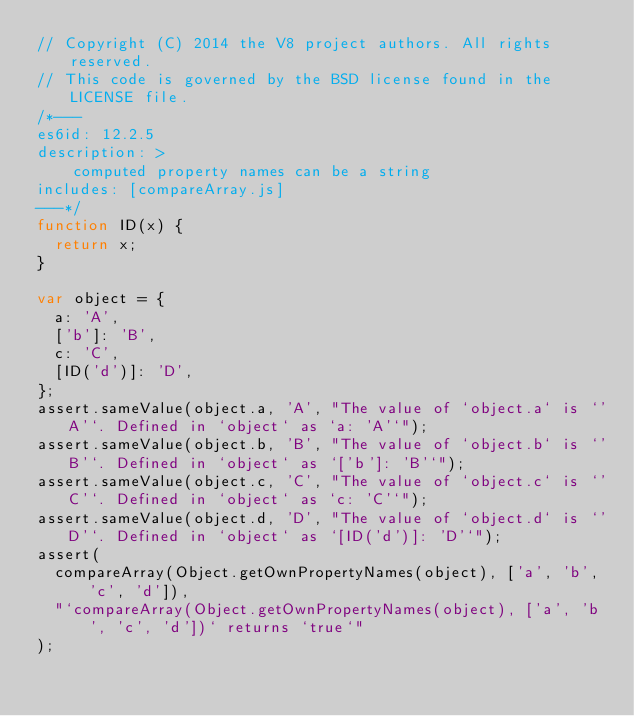Convert code to text. <code><loc_0><loc_0><loc_500><loc_500><_JavaScript_>// Copyright (C) 2014 the V8 project authors. All rights reserved.
// This code is governed by the BSD license found in the LICENSE file.
/*---
es6id: 12.2.5
description: >
    computed property names can be a string
includes: [compareArray.js]
---*/
function ID(x) {
  return x;
}

var object = {
  a: 'A',
  ['b']: 'B',
  c: 'C',
  [ID('d')]: 'D',
};
assert.sameValue(object.a, 'A', "The value of `object.a` is `'A'`. Defined in `object` as `a: 'A'`");
assert.sameValue(object.b, 'B', "The value of `object.b` is `'B'`. Defined in `object` as `['b']: 'B'`");
assert.sameValue(object.c, 'C', "The value of `object.c` is `'C'`. Defined in `object` as `c: 'C'`");
assert.sameValue(object.d, 'D', "The value of `object.d` is `'D'`. Defined in `object` as `[ID('d')]: 'D'`");
assert(
  compareArray(Object.getOwnPropertyNames(object), ['a', 'b', 'c', 'd']),
  "`compareArray(Object.getOwnPropertyNames(object), ['a', 'b', 'c', 'd'])` returns `true`"
);
</code> 